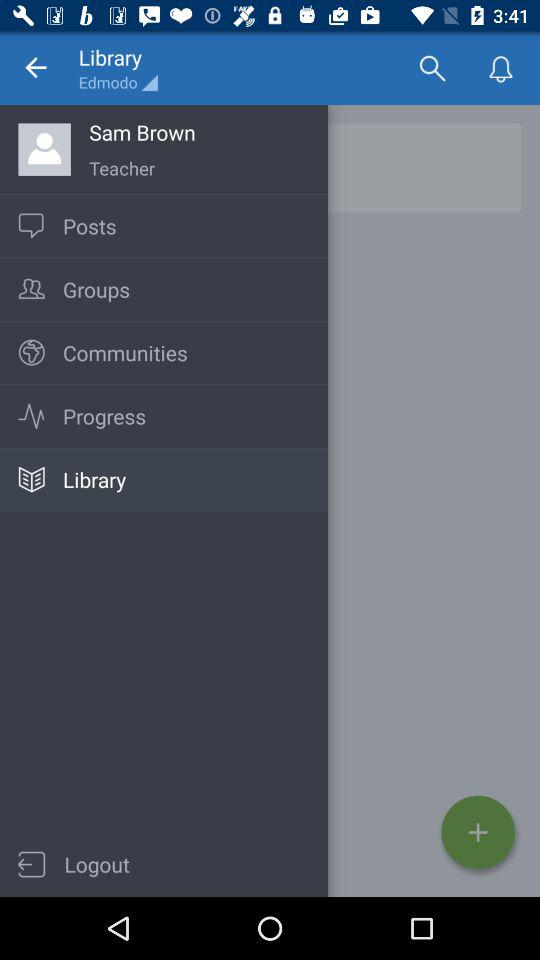What is the profile name? The profile name is Sam Brown. 